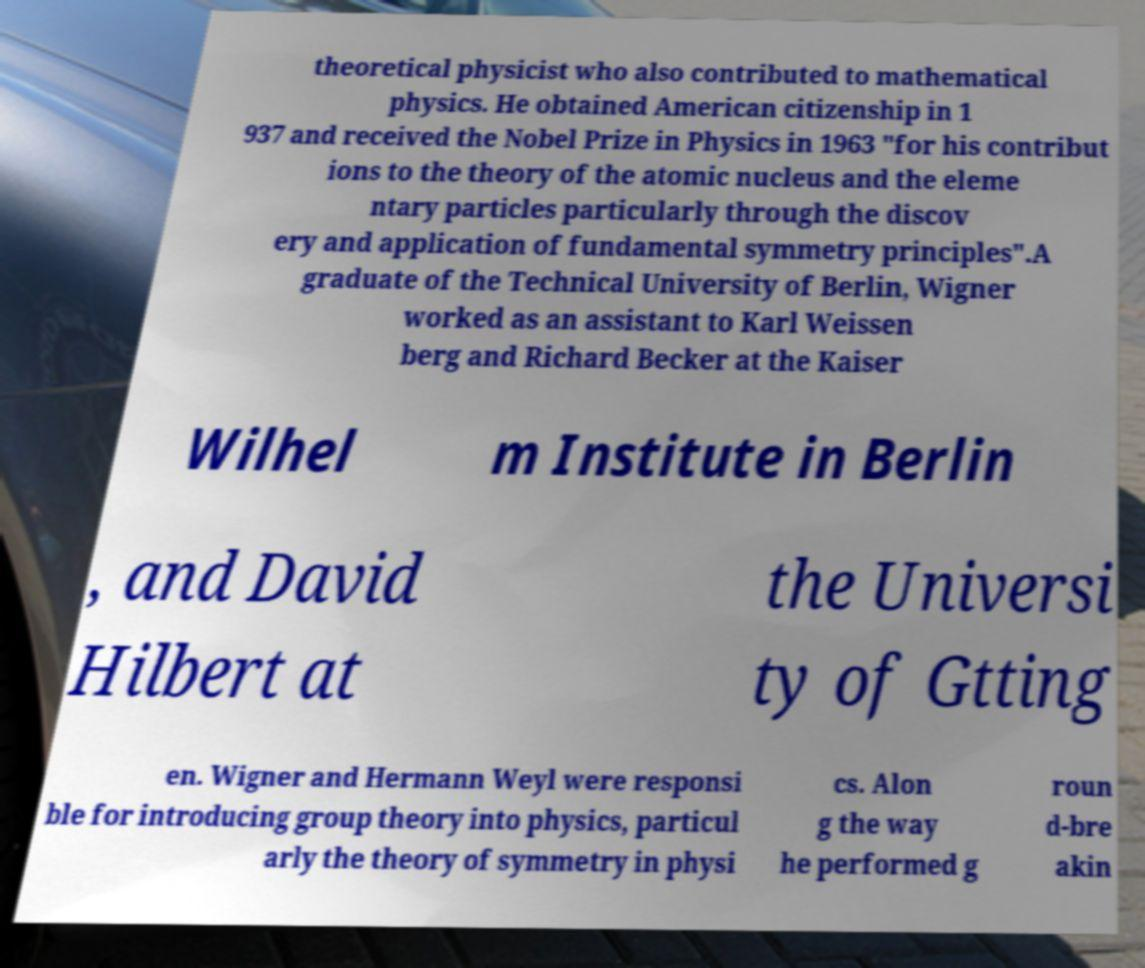I need the written content from this picture converted into text. Can you do that? theoretical physicist who also contributed to mathematical physics. He obtained American citizenship in 1 937 and received the Nobel Prize in Physics in 1963 "for his contribut ions to the theory of the atomic nucleus and the eleme ntary particles particularly through the discov ery and application of fundamental symmetry principles".A graduate of the Technical University of Berlin, Wigner worked as an assistant to Karl Weissen berg and Richard Becker at the Kaiser Wilhel m Institute in Berlin , and David Hilbert at the Universi ty of Gtting en. Wigner and Hermann Weyl were responsi ble for introducing group theory into physics, particul arly the theory of symmetry in physi cs. Alon g the way he performed g roun d-bre akin 